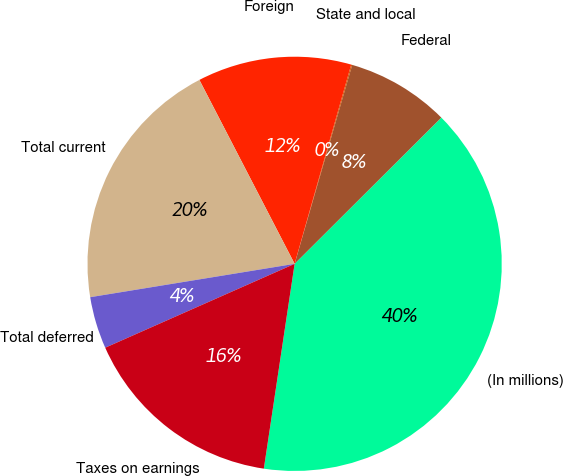<chart> <loc_0><loc_0><loc_500><loc_500><pie_chart><fcel>(In millions)<fcel>Federal<fcel>State and local<fcel>Foreign<fcel>Total current<fcel>Total deferred<fcel>Taxes on earnings<nl><fcel>39.85%<fcel>8.04%<fcel>0.08%<fcel>12.01%<fcel>19.97%<fcel>4.06%<fcel>15.99%<nl></chart> 